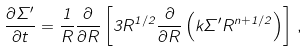<formula> <loc_0><loc_0><loc_500><loc_500>\frac { \partial \Sigma ^ { \prime } } { \partial t } = \frac { 1 } { R } \frac { \partial } { \partial R } \left [ 3 R ^ { 1 / 2 } \frac { \partial } { \partial R } \left ( k \Sigma ^ { \prime } R ^ { n + 1 / 2 } \right ) \right ] \, ,</formula> 